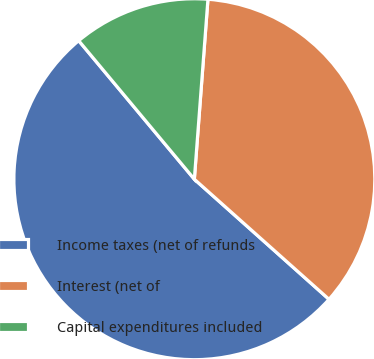Convert chart to OTSL. <chart><loc_0><loc_0><loc_500><loc_500><pie_chart><fcel>Income taxes (net of refunds<fcel>Interest (net of<fcel>Capital expenditures included<nl><fcel>52.34%<fcel>35.39%<fcel>12.27%<nl></chart> 